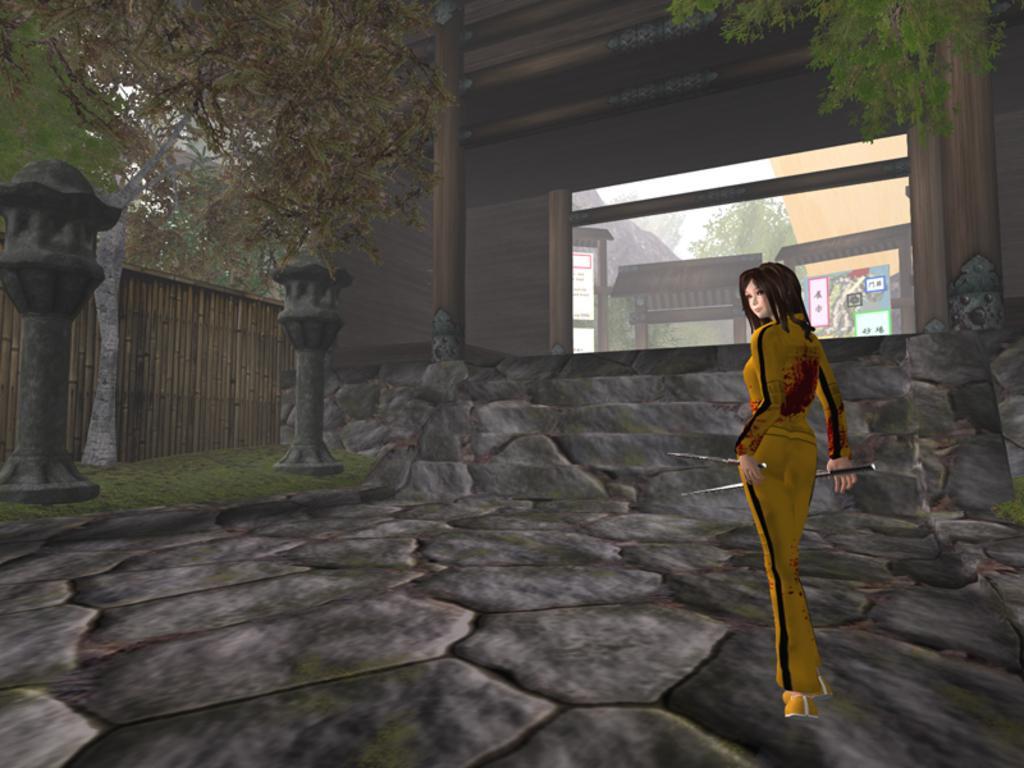In one or two sentences, can you explain what this image depicts? In this image we can see an animated picture of a woman holding sticks in her hand. In the background, we can see a window group of arches, statues, a group of trees, poles and a fence. 